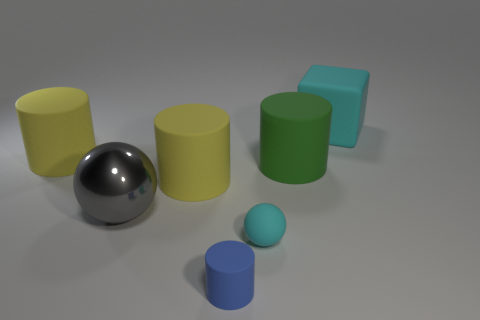Subtract 2 cylinders. How many cylinders are left? 2 Subtract all green cylinders. How many cylinders are left? 3 Subtract all big matte cylinders. How many cylinders are left? 1 Subtract all cyan cylinders. Subtract all green balls. How many cylinders are left? 4 Add 1 big green things. How many objects exist? 8 Subtract all cylinders. How many objects are left? 3 Add 6 tiny rubber blocks. How many tiny rubber blocks exist? 6 Subtract 2 yellow cylinders. How many objects are left? 5 Subtract all tiny gray metallic blocks. Subtract all tiny cyan matte balls. How many objects are left? 6 Add 3 green cylinders. How many green cylinders are left? 4 